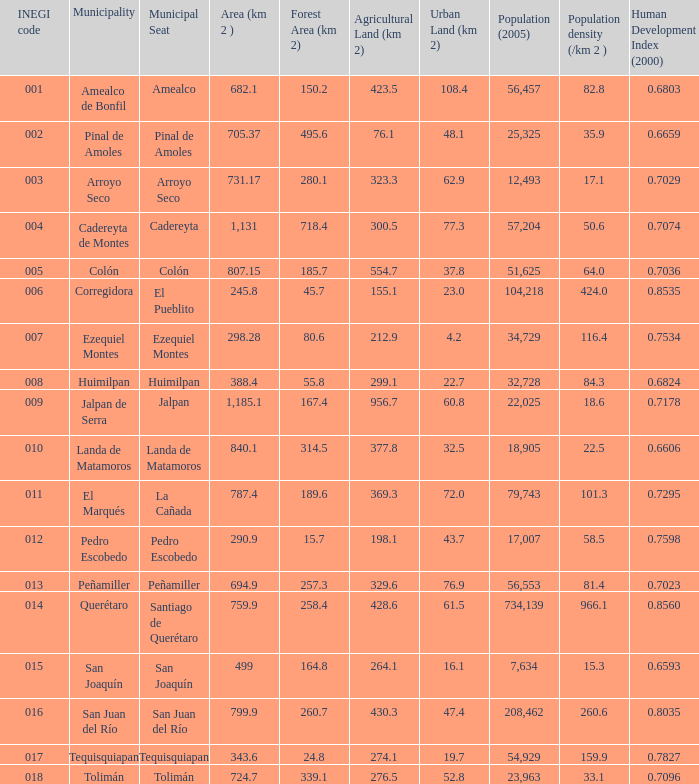WHat is the amount of Human Development Index (2000) that has a Population (2005) of 54,929, and an Area (km 2 ) larger than 343.6? 0.0. 